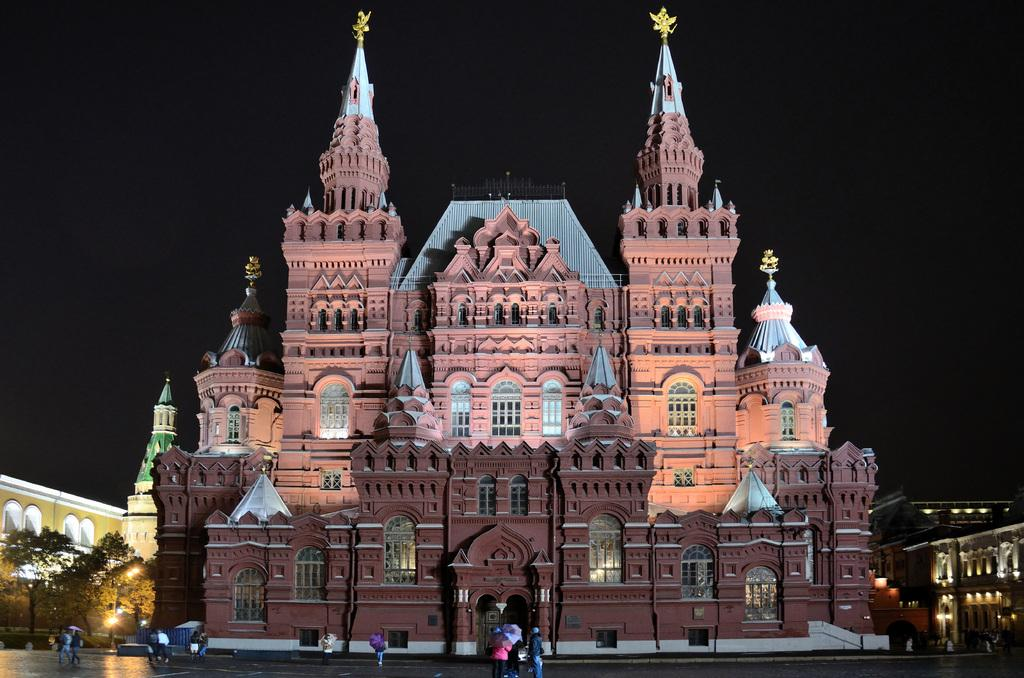What type of structures can be seen in the image? There are buildings in the image. What else is visible in the image besides the buildings? There are lights, people, trees, and the sky visible in the image. How many mice can be seen running around the buildings in the image? There are no mice present in the image. What type of insect can be seen flying near the lights in the image? There are no insects visible in the image. 